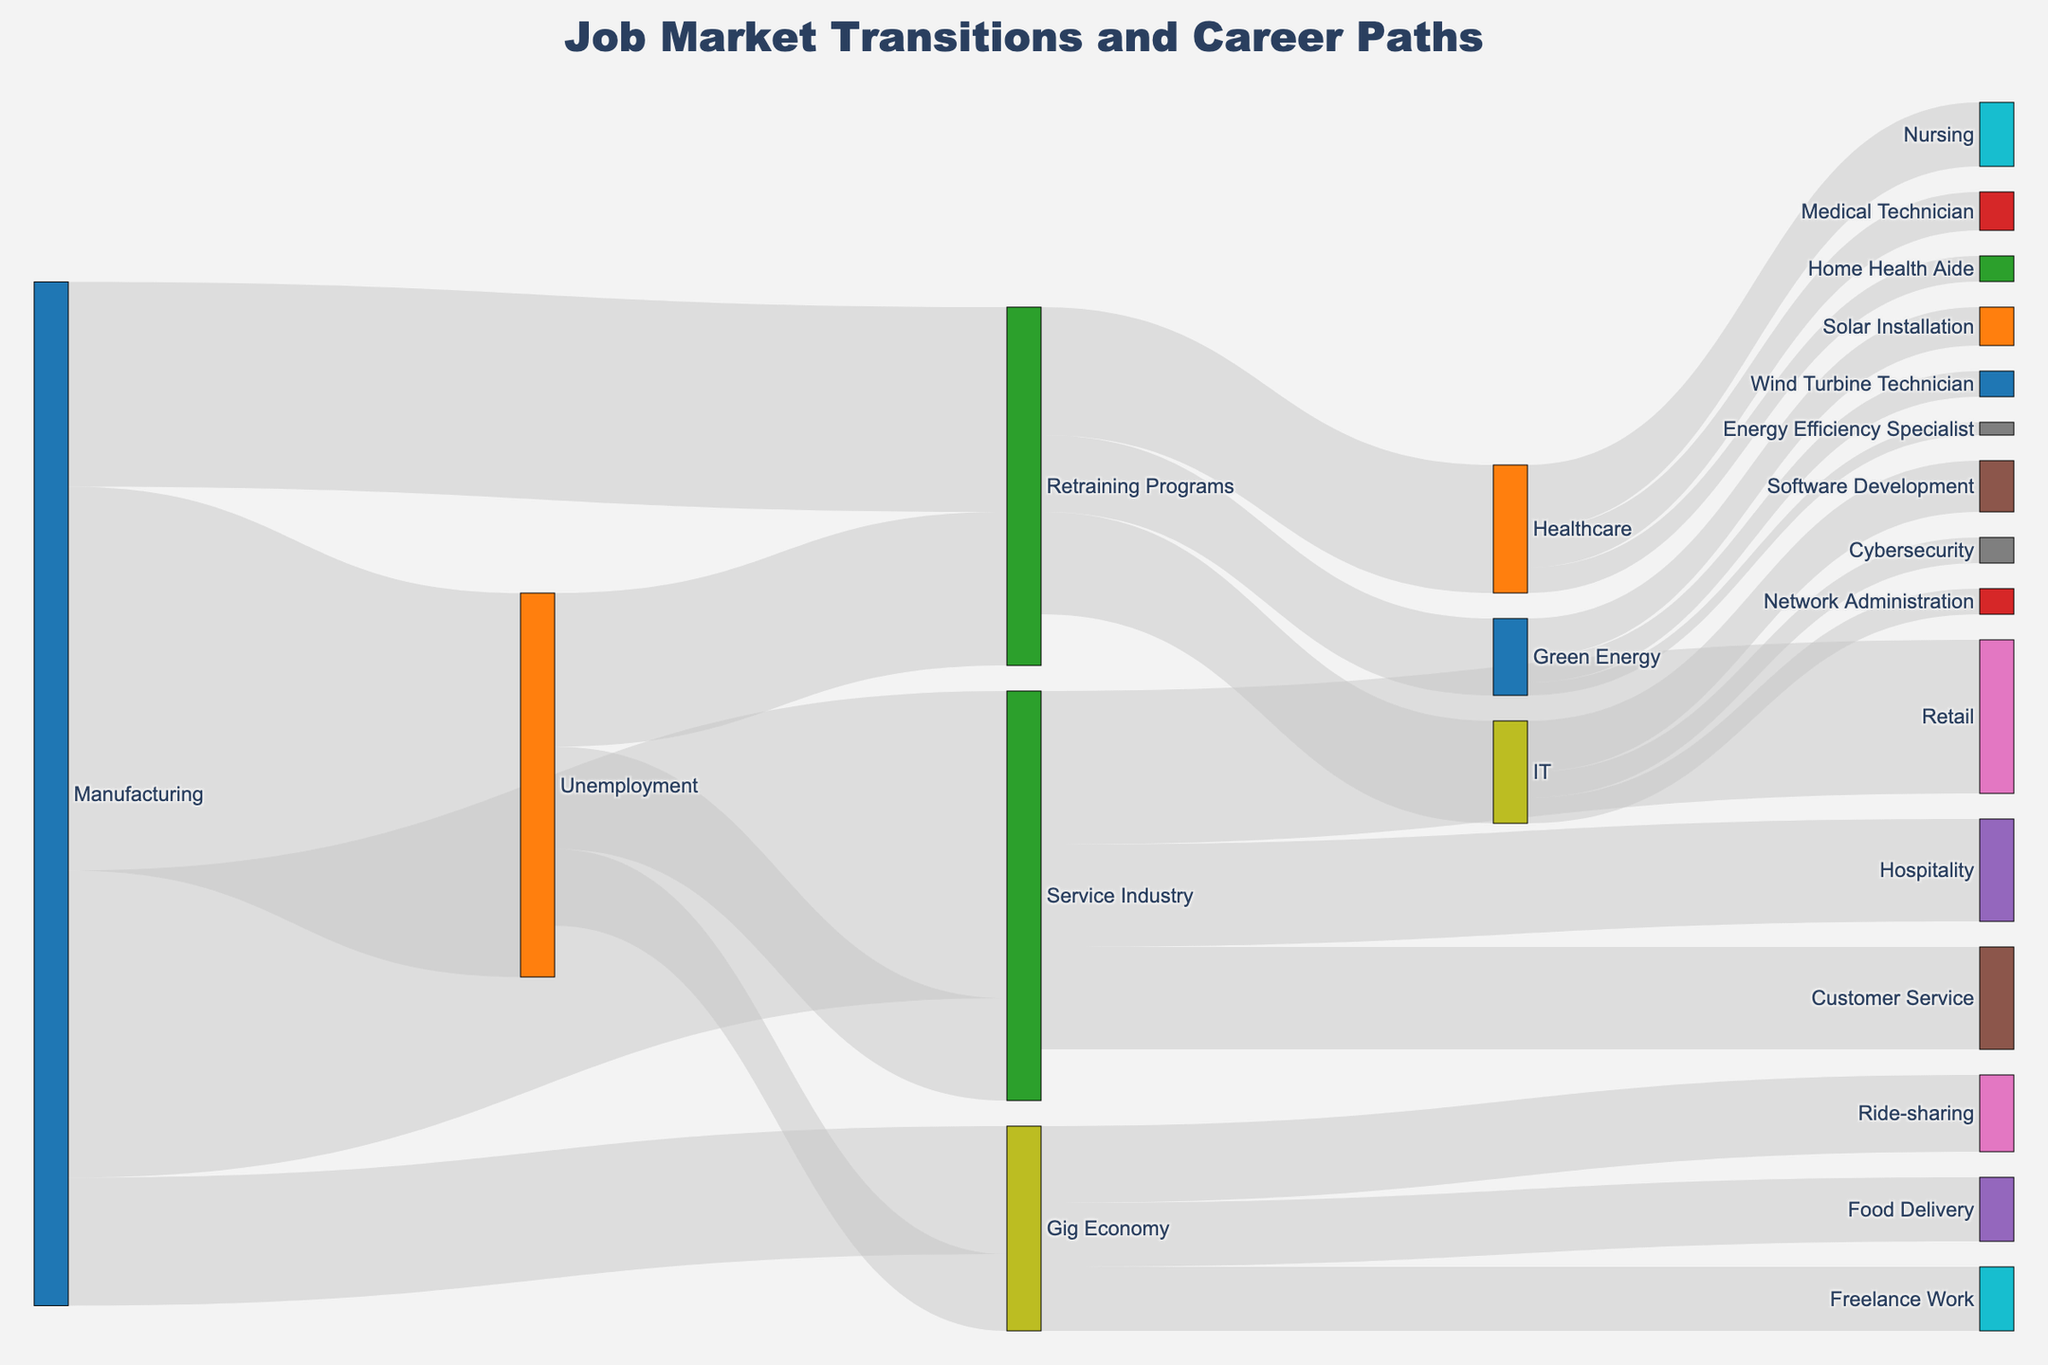what is the most common transition from manufacturing? By looking at the figure, the transitions from manufacturing can be seen leading to unemployment, retraining programs, service industry, and gig economy. The arrow with the widest band represents the most common transition. According to the visual information in the diagram, the broadest arrow goes from manufacturing to unemployment with a value of 1500.
Answer: Unemployment How many people went from retraining programs to IT? The Sankey diagram shows the transitions from retraining programs to different sectors with varying widths of arrows indicating the number of people. To find the specific transition to IT, we locate the arrow labeled as going towards IT from retraining programs. The figure shows a transition of 400 people from retraining programs to IT.
Answer: 400 Which final destination has the least number of people in the gig economy? Gigs in the gig economy illustrated are ride-sharing, food delivery, and freelance work. By comparing the widths of arrows leading to these destinations, we find the thinnest arrow to determine the least number of people. The diagram indicates that ride-sharing (300), food delivery (250), and freelance work (250). The smallest groups being food delivery and freelance work each receive 250 workers.
Answer: Food Delivery and Freelance Work What’s the total number of people transitioning from manufacturing? To find the total number of transitions from manufacturing, we sum up all the values associated with transitions from that node. The diagram shows transitions as 1500 to unemployment, 800 to retraining programs, 1200 to service industry and 500 to gig economy. Summing these gives 1500 + 800 + 1200 + 500 = 4000.
Answer: 4000 How many more people transitioned to the IT sector compared to the Healthcare sector after retraining programs? The diagram shows transitions from retraining programs to IT (400), Healthcare (500), and Green Energy (300). To find how many more people transitioned to IT compared to Healthcare, we need to perform the difference 500 - 400 = 100. Hence, 100 more people transitioned to Healthcare than IT.
Answer: 100 Which transition from unemployment has the fewest people? Observing the arrows from the unemployment node, we see transitions to retraining programs, service industry, and gig economy. By inspecting the widths and values, there are 600 to retraining programs, 400 to the service industry, and 300 to the gig economy. The fewest transition is the gig economy with 300.
Answer: Gig Economy What is the most common job in the service industry based on transitions from the service industry sector? In the Sankey diagram, the service industry transitions are divided into retail, hospitality, and customer service. To identify the most common job in this sector, we observe the widest arrow among these transitions. According to the diagram, retail receives the largest transition with a value of 600, indicating it's the most common job in the service industry.
Answer: Retail How many people in total transitioned into the healthcare sub-sector from the gig economy? To find the total number of people entering the healthcare sub-sector from the gig economy, we identify all relevant transitions. The diagram shows transitions from healthcare include nursing (250), medical technician (150), and home health aide (100). Summing these gives 250 + 150 + 100 = 500.
Answer: 500 What are the total number of people moving from unemployment to retraining programs and subsequently into IT? We follow the path from unemployment to retraining programs and then into IT. According to the diagram, 600 people move from unemployment to retraining programs and 400 out of these move into IT. Thus, the final count of people moving from unemployment to IT through retraining programs is 400.
Answer: 400 